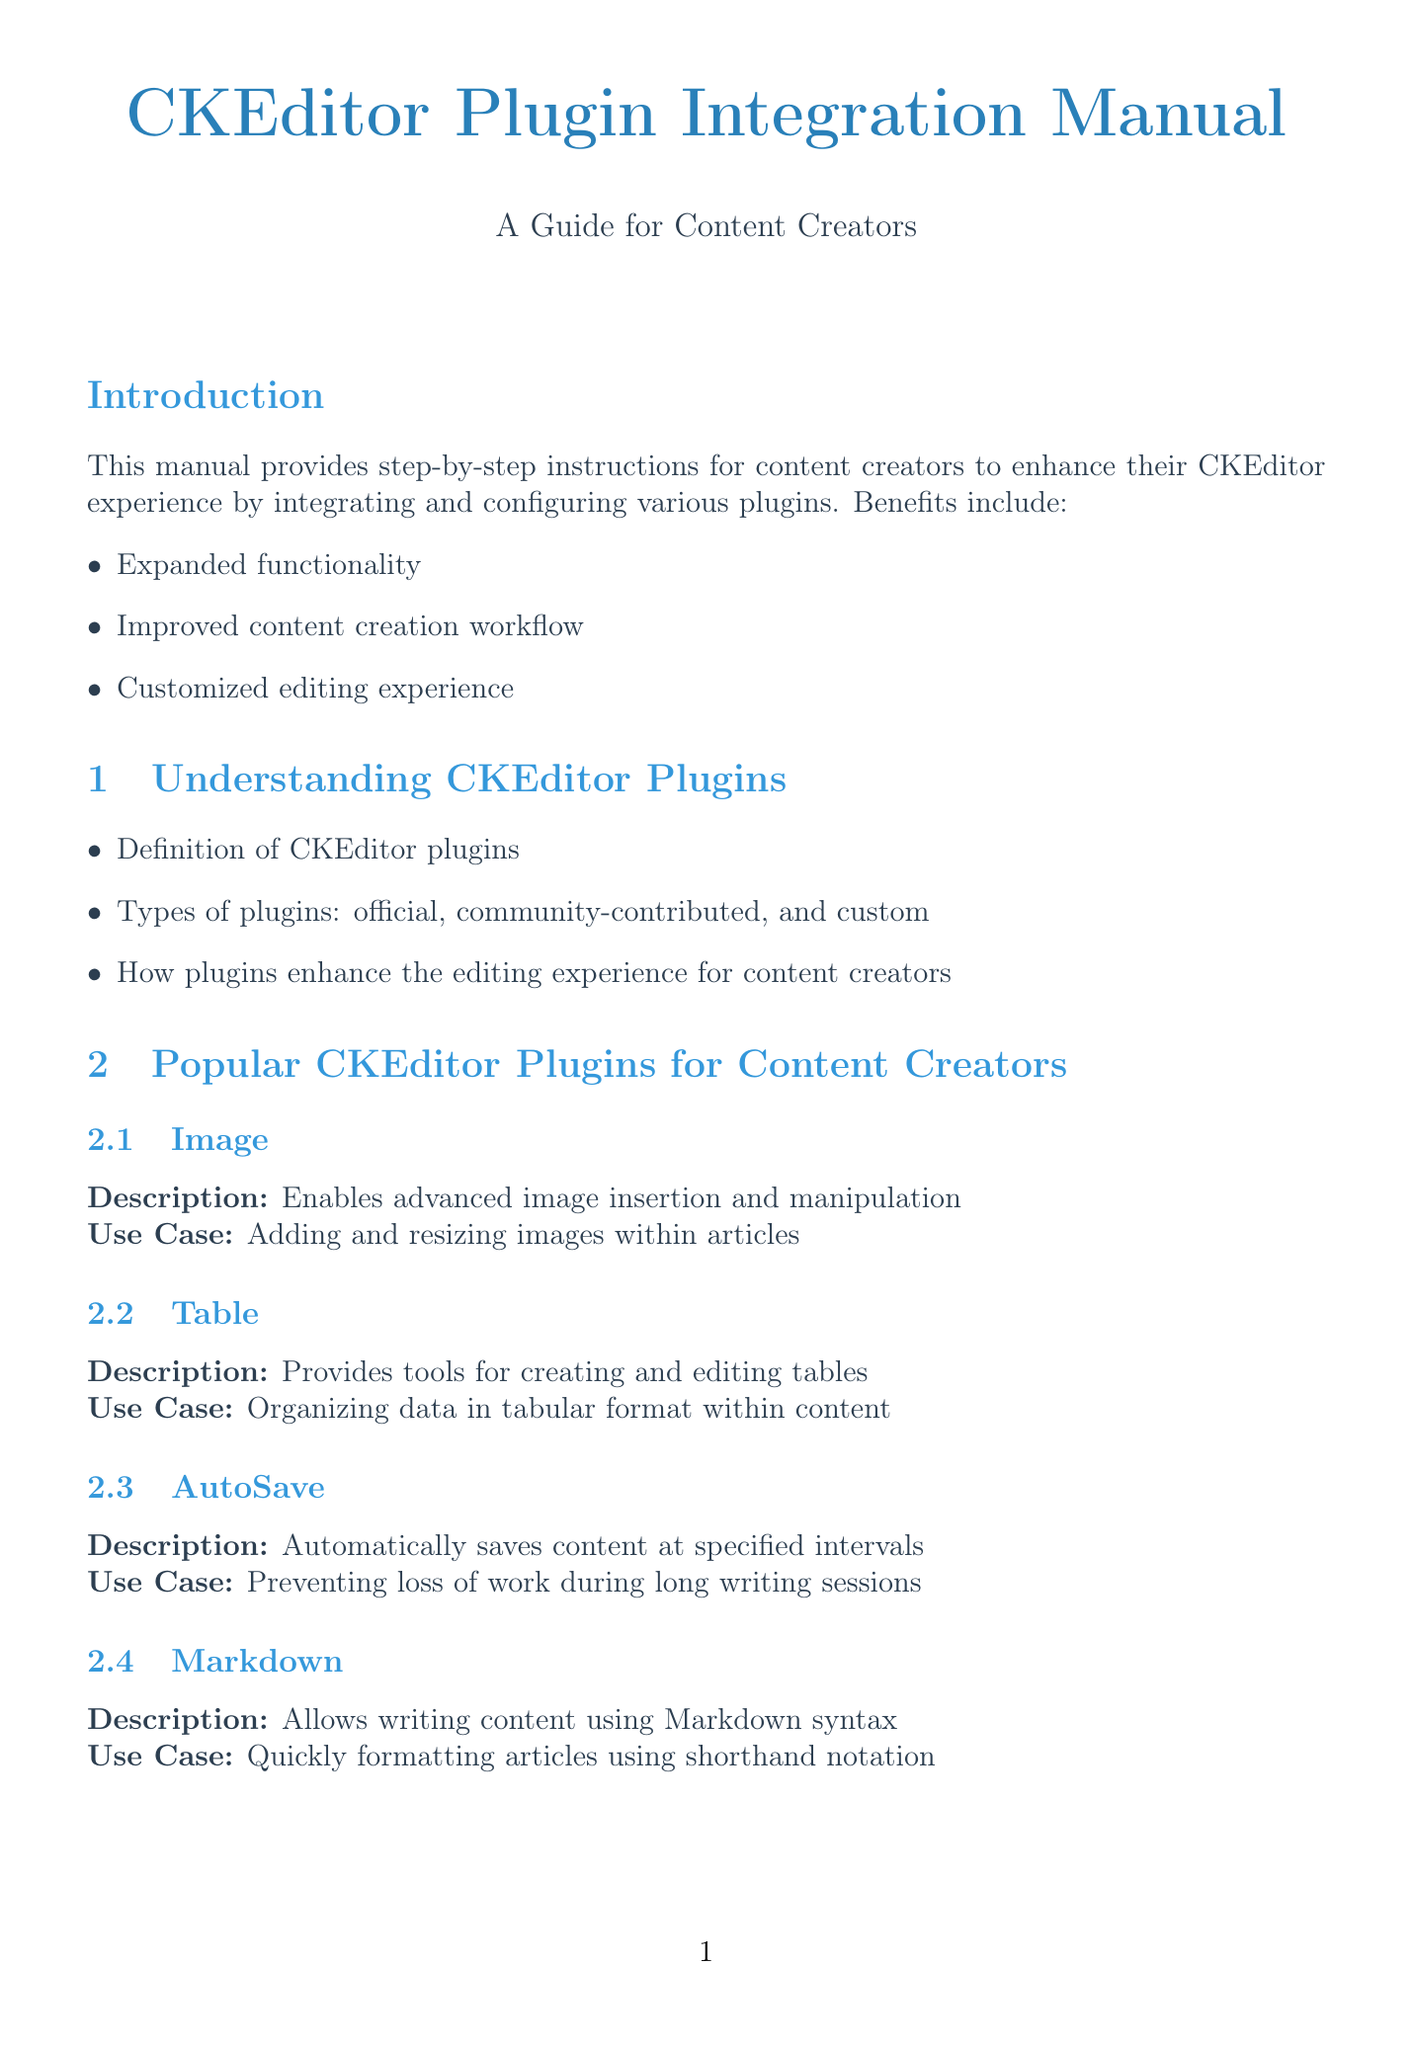What are the benefits of using CKEditor plugins? The benefits include expanded functionality, improved content creation workflow, and a customized editing experience.
Answer: Expanded functionality, improved content creation workflow, customized editing experience Name one popular CKEditor plugin. The document lists several popular plugins, including Image, Table, AutoSave, and Markdown.
Answer: Image What step follows the extraction of plugin files in the adding plugins process? After extracting the plugin files, the next step is to update your CKEditor configuration to include the new plugin.
Answer: Update your CKEditor configuration to include the new plugin What is the common problem if a plugin is not loading? The solution to a plugin not loading is to verify the plugin files are in the correct directory and properly referenced in the configuration.
Answer: Verify the plugin files are in the correct directory What configuration file is accessed for plugin configuration? The configuration file usually accessed is named config.js.
Answer: config.js How many steps are listed for adding plugins to CKEditor? There are four steps outlined for adding plugins in the document.
Answer: Four steps What should be documented for easy reference and maintenance? The manual advises documenting any custom configurations for easy reference and maintenance.
Answer: Custom configurations What type of plugins are listed as popular for content creators? The popular plugin types specified include official, community-contributed, and custom plugins.
Answer: Official, community-contributed, custom How can performance issues be addressed according to the document? To address performance issues, the document suggests monitoring editor performance and considering removing unused plugins.
Answer: Monitor editor performance and consider removing unused plugins 